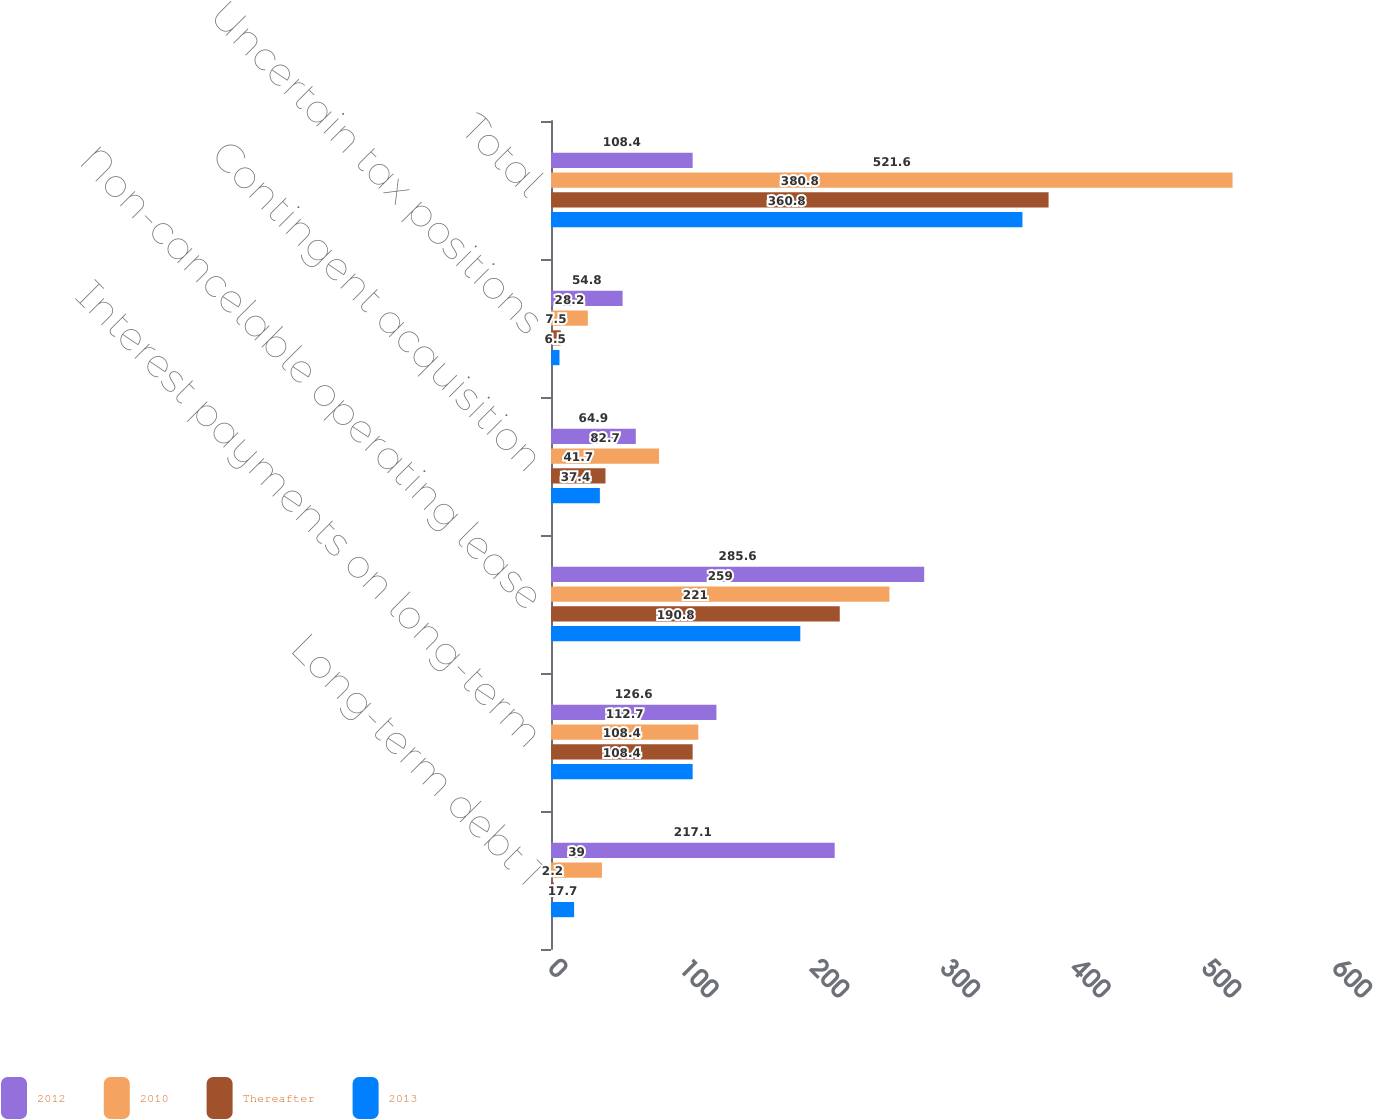Convert chart. <chart><loc_0><loc_0><loc_500><loc_500><stacked_bar_chart><ecel><fcel>Long-term debt 1<fcel>Interest payments on long-term<fcel>Non-cancelable operating lease<fcel>Contingent acquisition<fcel>Uncertain tax positions<fcel>Total<nl><fcel>2012<fcel>217.1<fcel>126.6<fcel>285.6<fcel>64.9<fcel>54.8<fcel>108.4<nl><fcel>2010<fcel>39<fcel>112.7<fcel>259<fcel>82.7<fcel>28.2<fcel>521.6<nl><fcel>Thereafter<fcel>2.2<fcel>108.4<fcel>221<fcel>41.7<fcel>7.5<fcel>380.8<nl><fcel>2013<fcel>17.7<fcel>108.4<fcel>190.8<fcel>37.4<fcel>6.5<fcel>360.8<nl></chart> 